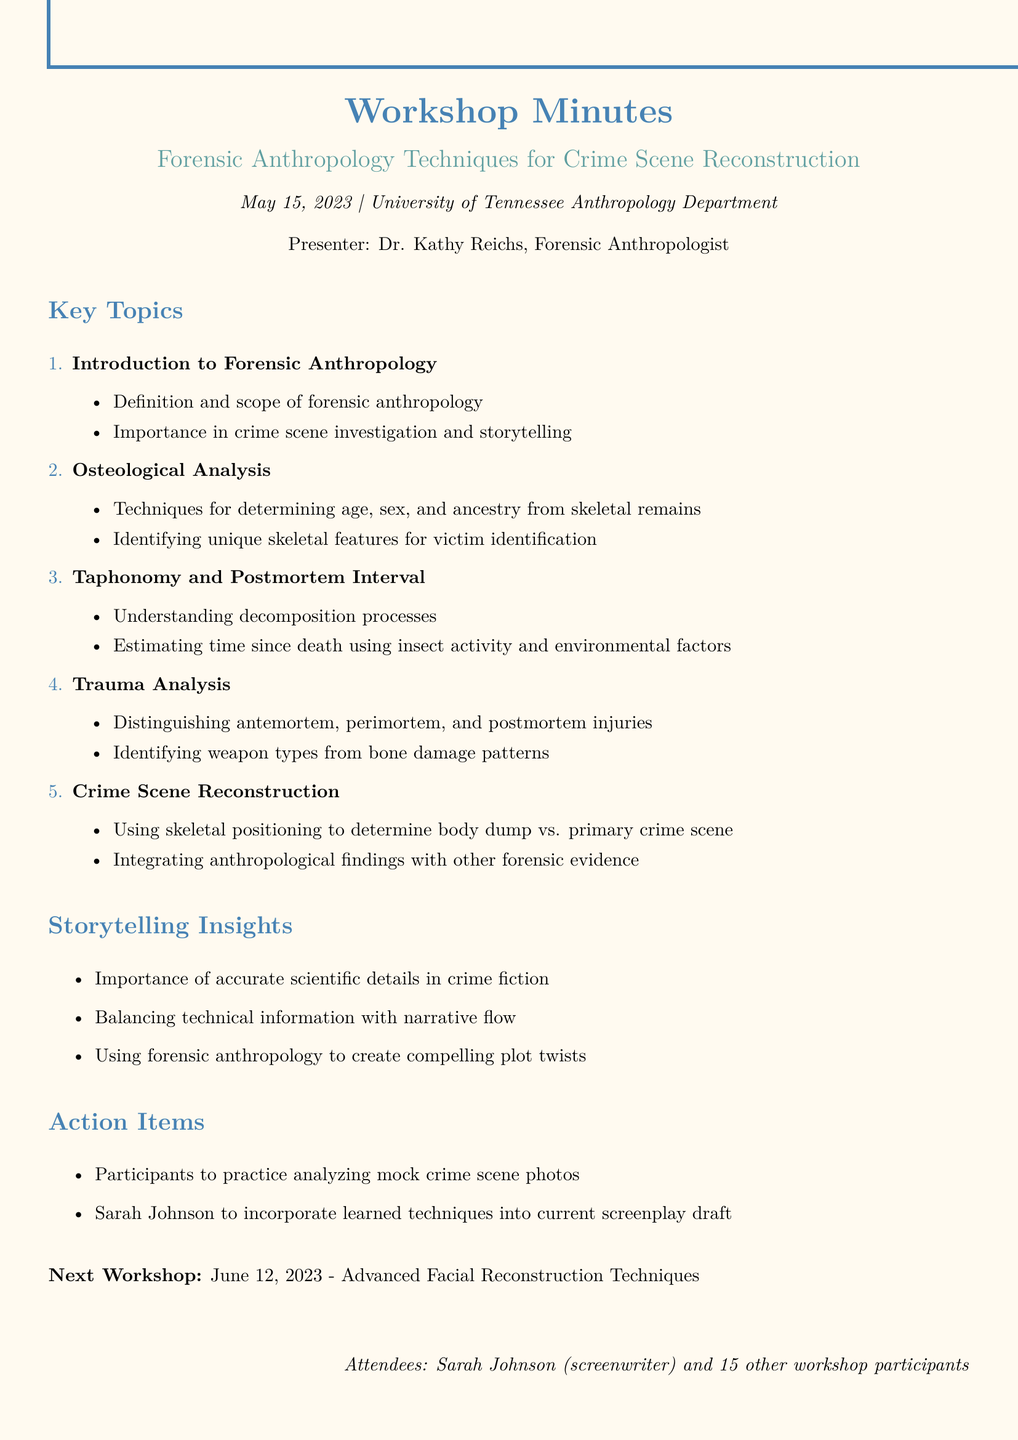what is the workshop title? The title of the workshop is mentioned at the beginning of the document.
Answer: Forensic Anthropology Techniques for Crime Scene Reconstruction who presented the workshop? The presenter's name is listed under the workshop details.
Answer: Dr. Kathy Reichs what was the location of the workshop? The location is noted in the header of the document.
Answer: University of Tennessee Anthropology Department what is one key topic discussed in the workshop? The document lists multiple key topics discussed during the workshop.
Answer: Introduction to Forensic Anthropology how many attendees were there? The document specifies the number of attendees at the end.
Answer: 16 what is an action item for Sarah Johnson? The action items section details tasks assigned to participants, specifically to Sarah Johnson.
Answer: Incorporate learned techniques into current screenplay draft what is the date of the next workshop? The information about the next workshop can be found near the end of the document.
Answer: June 12, 2023 what insight is mentioned about storytelling? The storytelling insights section highlights several important aspects related to crime fiction.
Answer: Importance of accurate scientific details in crime fiction how many key topics are listed in the document? The number of key topics can be inferred from the list presented in the document.
Answer: 5 